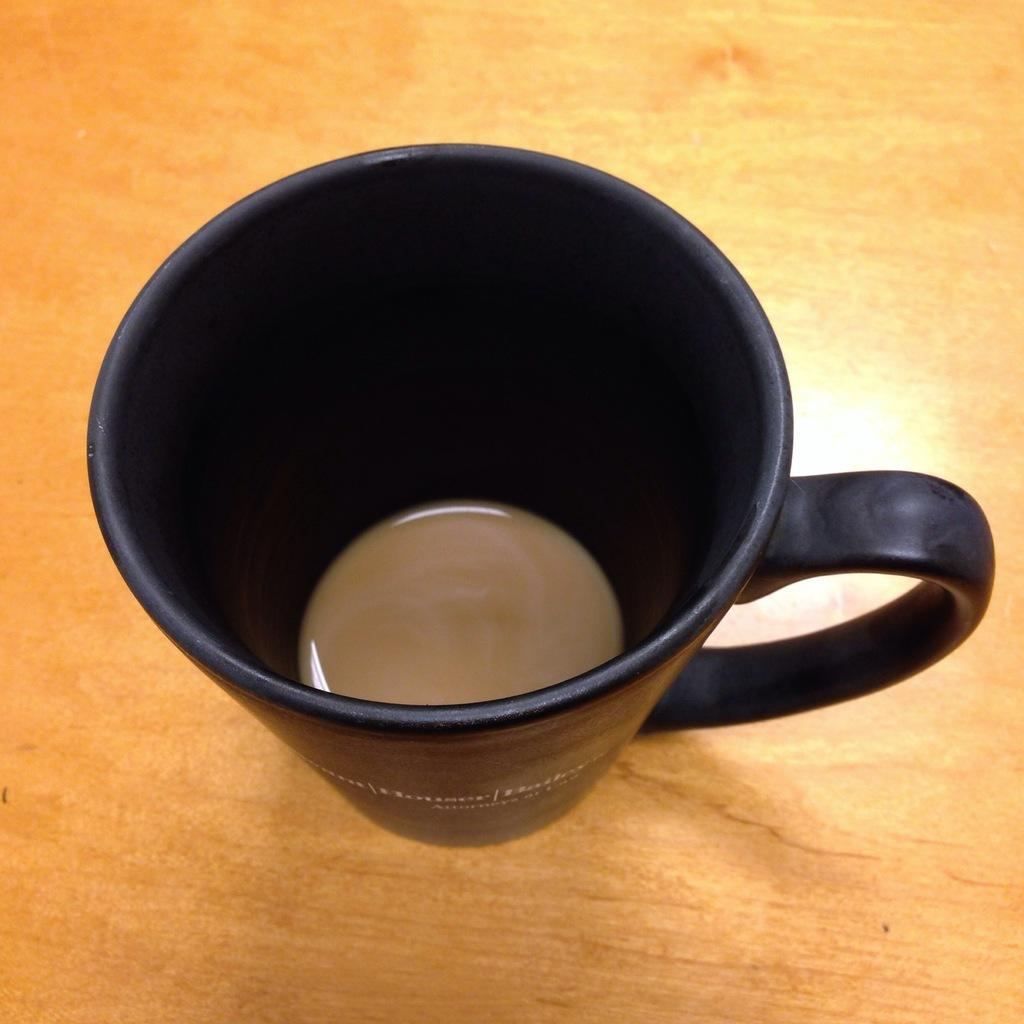What is in the cup that is visible in the image? There is tea in the cup. Where is the cup located in the image? The cup is on a table. What type of leather is used to make the story in the image? There is no story or leather present in the image; it features a cup with tea on a table. 